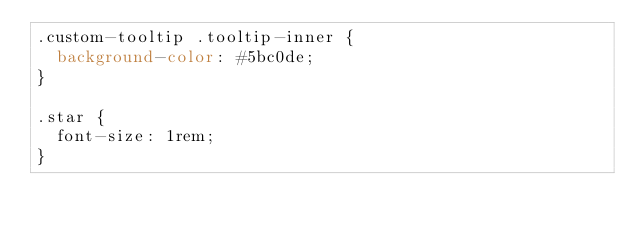<code> <loc_0><loc_0><loc_500><loc_500><_CSS_>.custom-tooltip .tooltip-inner {
  background-color: #5bc0de;
}

.star {
  font-size: 1rem;
}</code> 